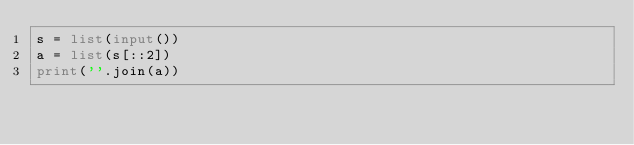<code> <loc_0><loc_0><loc_500><loc_500><_Python_>s = list(input())
a = list(s[::2])
print(''.join(a))</code> 